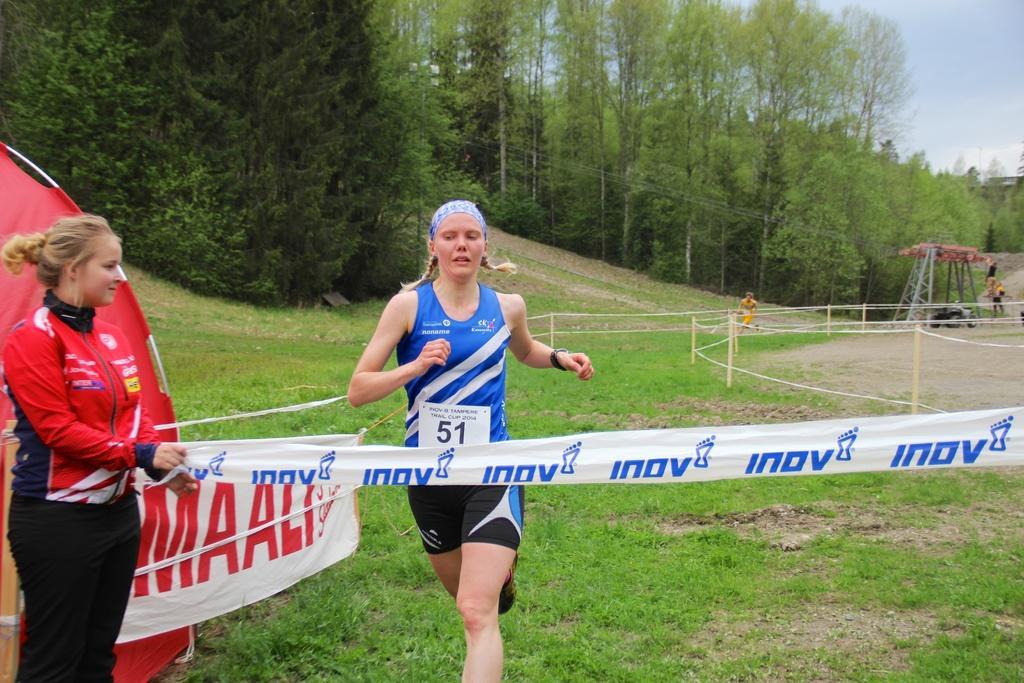Describe this image in one or two sentences. In this picture i can see an object on the left side. I can also see two women among them the woman on the left side i holding a cloth in the hand. In the background i can see trees, grass and fence. On the right side i can see some objects on the ground. 